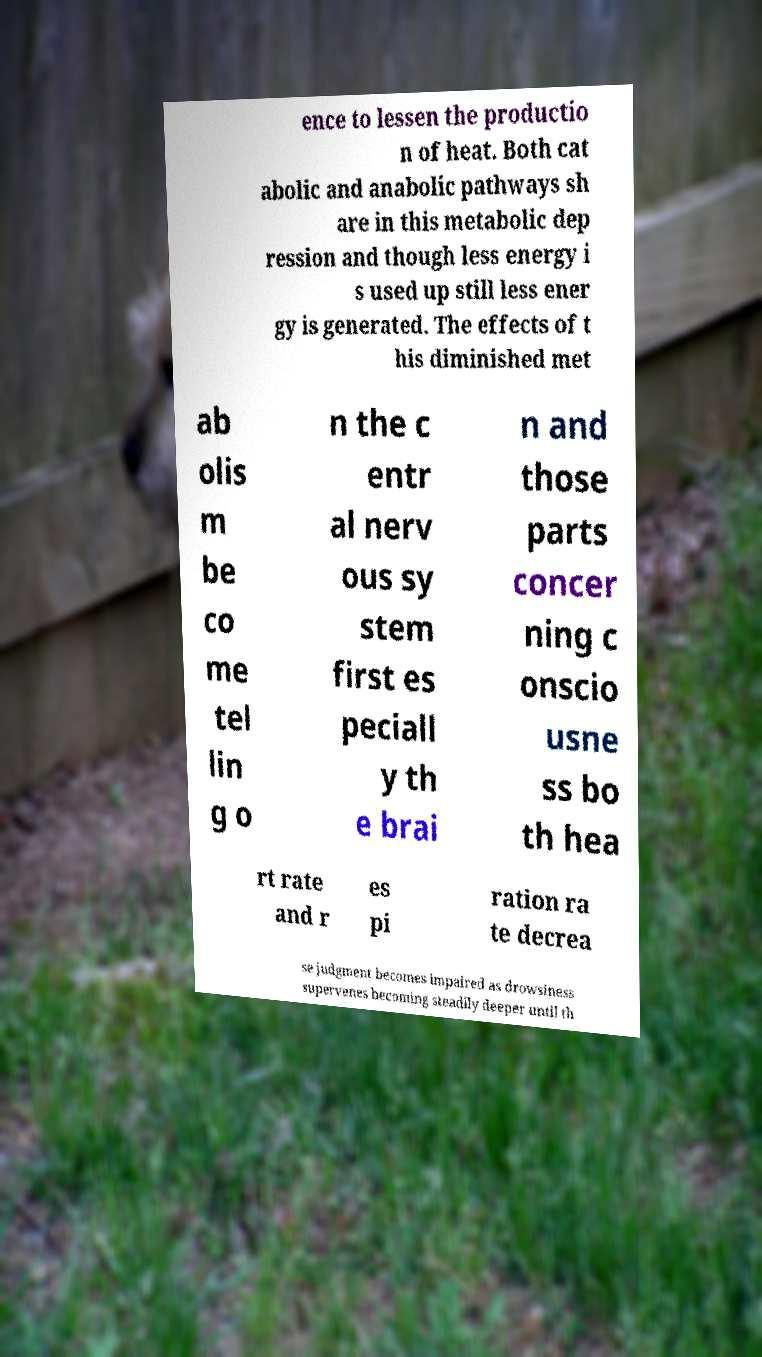For documentation purposes, I need the text within this image transcribed. Could you provide that? ence to lessen the productio n of heat. Both cat abolic and anabolic pathways sh are in this metabolic dep ression and though less energy i s used up still less ener gy is generated. The effects of t his diminished met ab olis m be co me tel lin g o n the c entr al nerv ous sy stem first es peciall y th e brai n and those parts concer ning c onscio usne ss bo th hea rt rate and r es pi ration ra te decrea se judgment becomes impaired as drowsiness supervenes becoming steadily deeper until th 